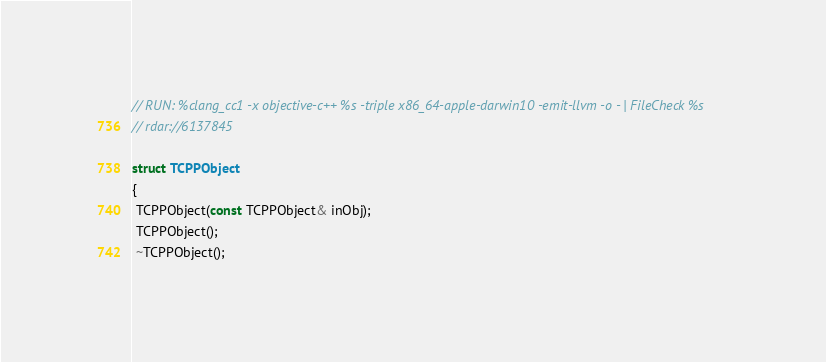<code> <loc_0><loc_0><loc_500><loc_500><_ObjectiveC_>// RUN: %clang_cc1 -x objective-c++ %s -triple x86_64-apple-darwin10 -emit-llvm -o - | FileCheck %s
// rdar://6137845

struct TCPPObject
{
 TCPPObject(const TCPPObject& inObj);
 TCPPObject();
 ~TCPPObject();</code> 